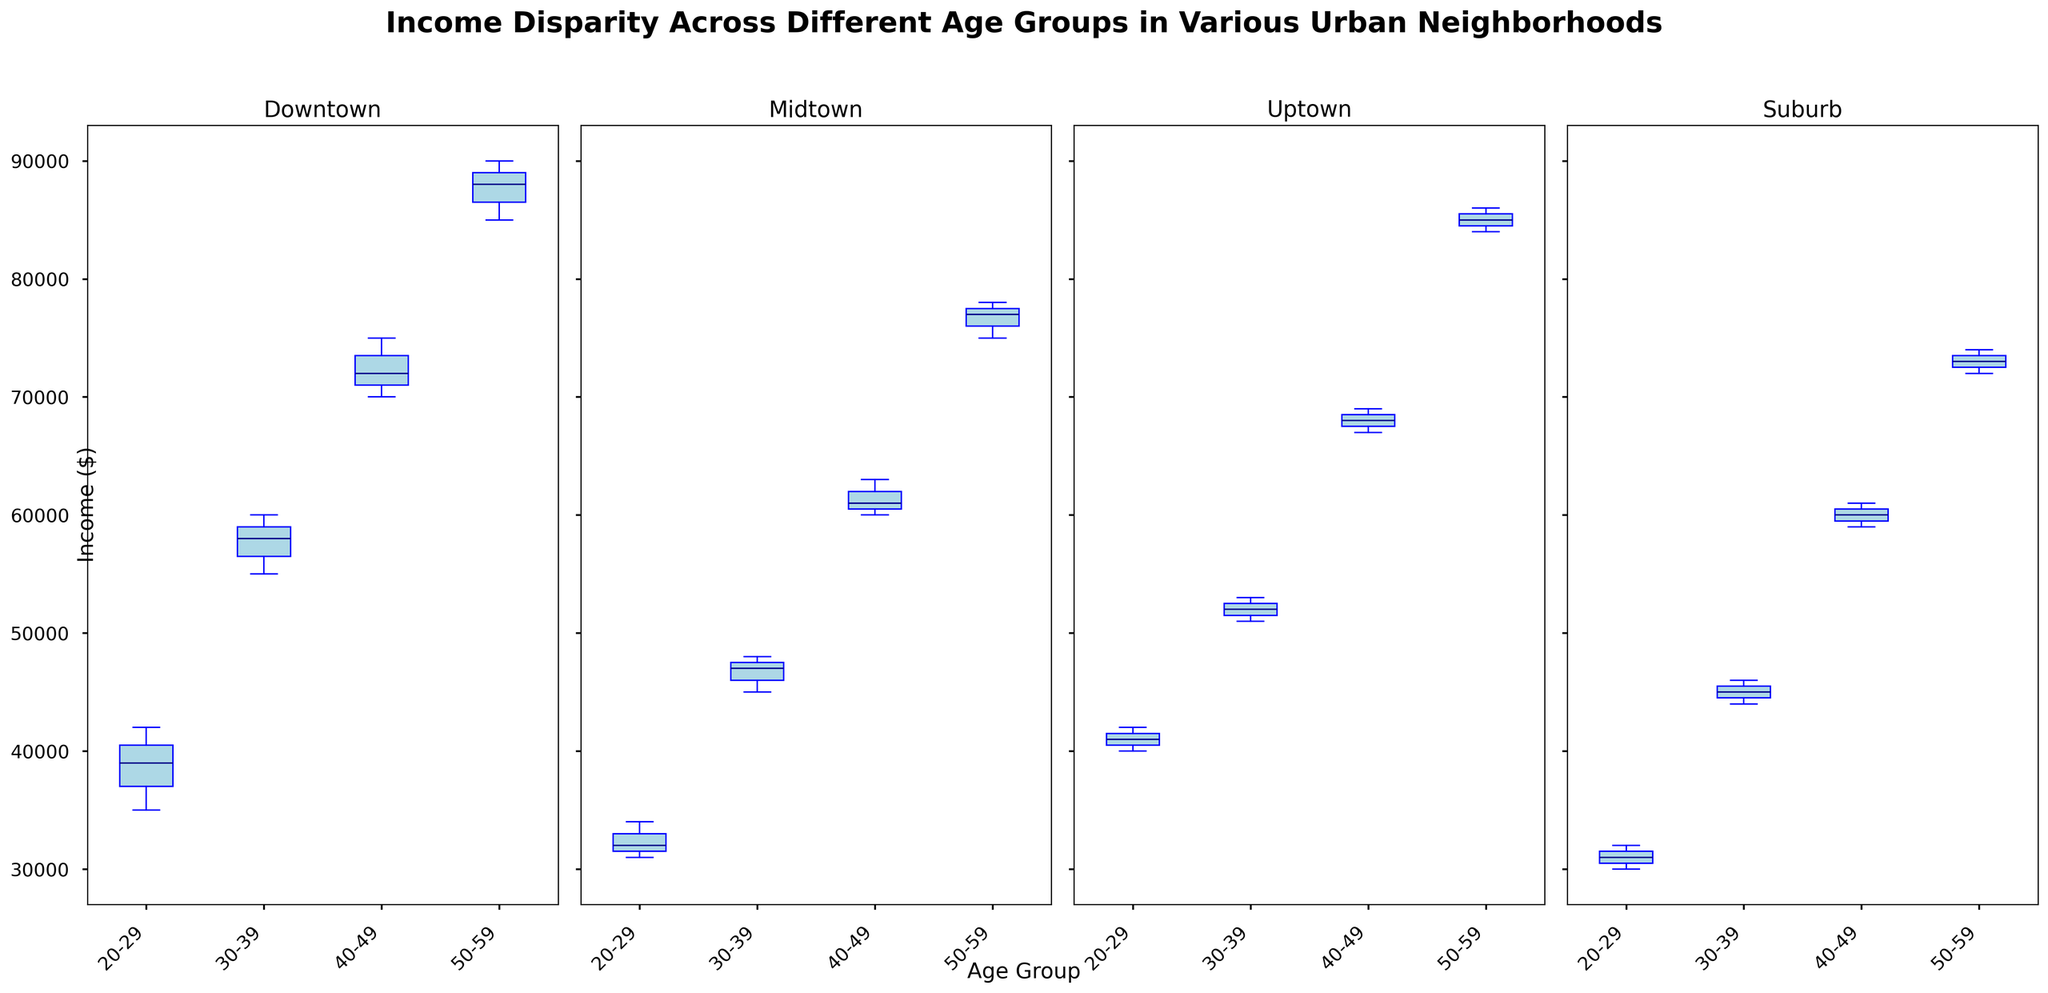What is the median income of the 50-59 age group in Downtown? To find the median income of the 50-59 age group in Downtown, look at the center line inside the box for that age group in the Downtown subplot. The median is where this line intersects with the y-axis.
Answer: \$88000 Which neighborhood has the highest median income among the 20-29 age group? To determine which neighborhood has the highest median income, locate the boxes for the 20-29 age groups in each subplot. Identify the median line in these boxes and compare their positions along the y-axis.
Answer: Uptown In Midtown, which age group shows the highest income range? Income range is represented by the distance between the bottom and top whiskers of the box plot. Compare these distances for each age group in the Midtown subplot.
Answer: 50-59 What is the interquartile range (IQR) for the 40-49 age group in Suburb? The IQR is the difference between the third quartile (top of the box) and the first quartile (bottom of the box) for the 40-49 age group in the Suburb subplot.
Answer: \$10000 Compare the median incomes between the 30-39 and 40-49 age groups in Uptown. Which age group has a higher median income? Locate the median lines within the boxes for the 30-39 and 40-49 age groups in the Uptown subplot. Compare their positions along the y-axis.
Answer: 40-49 age group In which neighborhood does the 50-59 age group have the smallest income disparity? Income disparity is represented by the length of the box for the 50-59 age group. Compare the lengths of these boxes across all subplots.
Answer: Suburb How does the income disparity of 20-29 age group in Downtown compare to the 40-49 age group in Midtown? Compare the lengths of the boxes for the 20-29 age group in Downtown and the 40-49 age group in Midtown. The longer the box, the greater the income disparity.
Answer: Greater in Downtown Does the 30-39 age group in Downtown have a higher median income than the 30-39 age group in Uptown? Compare the median lines within the boxes for the 30-39 age groups in Downtown and Uptown subplots.
Answer: Yes Between which age groups in Midtown is the difference in median incomes the largest? Calculate the differences between the median lines in each age group within the Midtown subplot and identify the largest difference.
Answer: 20-29 and 50-59 age groups Which neighborhood shows the least variation in income across all age groups? Look at the lengths of the boxes and whiskers for all age groups across all neighborhoods. The neighborhood with generally shorter boxes and whiskers indicates less variation.
Answer: Suburb 